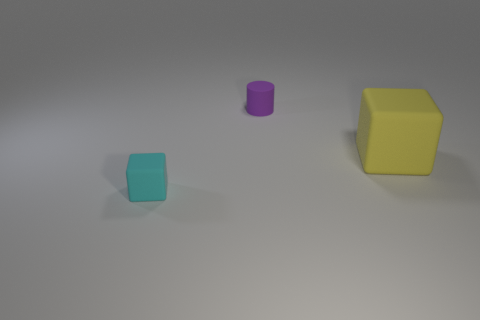Add 1 tiny matte cubes. How many objects exist? 4 Subtract all cubes. How many objects are left? 1 Add 2 large yellow objects. How many large yellow objects exist? 3 Subtract 0 red cylinders. How many objects are left? 3 Subtract all brown spheres. Subtract all big yellow cubes. How many objects are left? 2 Add 1 large rubber objects. How many large rubber objects are left? 2 